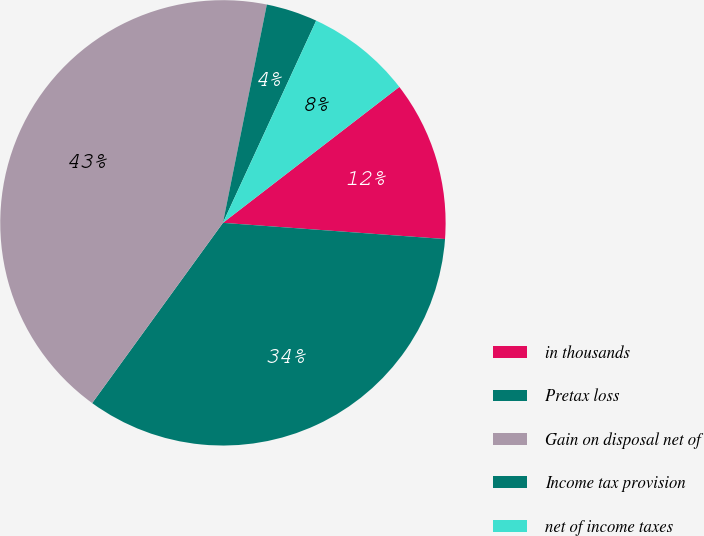Convert chart. <chart><loc_0><loc_0><loc_500><loc_500><pie_chart><fcel>in thousands<fcel>Pretax loss<fcel>Gain on disposal net of<fcel>Income tax provision<fcel>net of income taxes<nl><fcel>11.61%<fcel>33.83%<fcel>43.17%<fcel>3.72%<fcel>7.67%<nl></chart> 